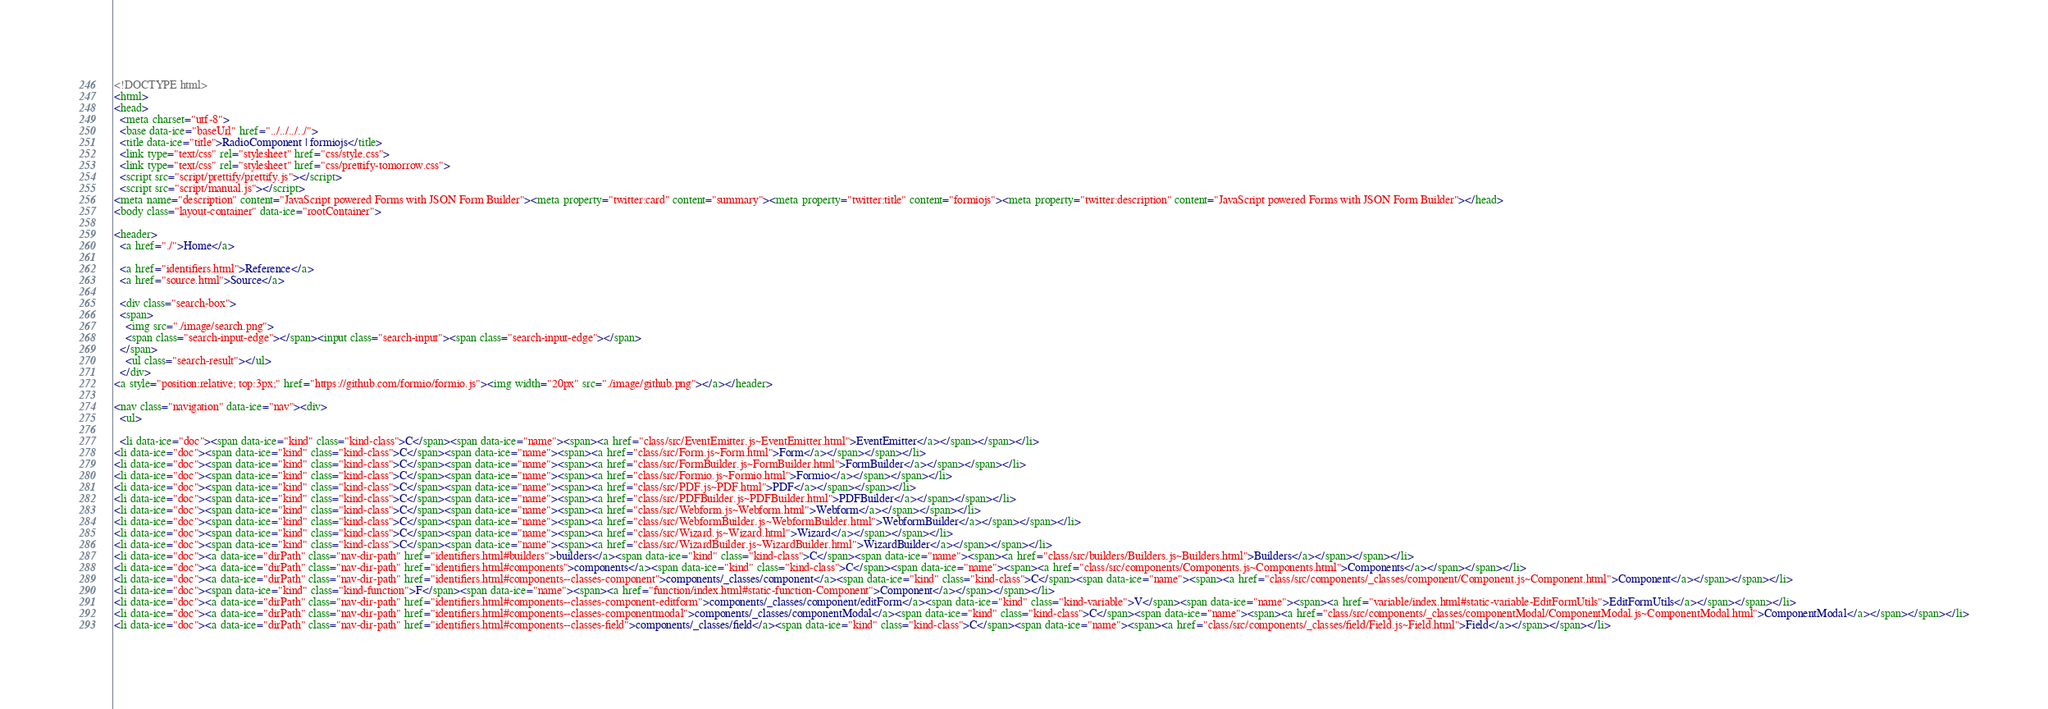<code> <loc_0><loc_0><loc_500><loc_500><_HTML_><!DOCTYPE html>
<html>
<head>
  <meta charset="utf-8">
  <base data-ice="baseUrl" href="../../../../">
  <title data-ice="title">RadioComponent | formiojs</title>
  <link type="text/css" rel="stylesheet" href="css/style.css">
  <link type="text/css" rel="stylesheet" href="css/prettify-tomorrow.css">
  <script src="script/prettify/prettify.js"></script>
  <script src="script/manual.js"></script>
<meta name="description" content="JavaScript powered Forms with JSON Form Builder"><meta property="twitter:card" content="summary"><meta property="twitter:title" content="formiojs"><meta property="twitter:description" content="JavaScript powered Forms with JSON Form Builder"></head>
<body class="layout-container" data-ice="rootContainer">

<header>
  <a href="./">Home</a>
  
  <a href="identifiers.html">Reference</a>
  <a href="source.html">Source</a>
  
  <div class="search-box">
  <span>
    <img src="./image/search.png">
    <span class="search-input-edge"></span><input class="search-input"><span class="search-input-edge"></span>
  </span>
    <ul class="search-result"></ul>
  </div>
<a style="position:relative; top:3px;" href="https://github.com/formio/formio.js"><img width="20px" src="./image/github.png"></a></header>

<nav class="navigation" data-ice="nav"><div>
  <ul>
    
  <li data-ice="doc"><span data-ice="kind" class="kind-class">C</span><span data-ice="name"><span><a href="class/src/EventEmitter.js~EventEmitter.html">EventEmitter</a></span></span></li>
<li data-ice="doc"><span data-ice="kind" class="kind-class">C</span><span data-ice="name"><span><a href="class/src/Form.js~Form.html">Form</a></span></span></li>
<li data-ice="doc"><span data-ice="kind" class="kind-class">C</span><span data-ice="name"><span><a href="class/src/FormBuilder.js~FormBuilder.html">FormBuilder</a></span></span></li>
<li data-ice="doc"><span data-ice="kind" class="kind-class">C</span><span data-ice="name"><span><a href="class/src/Formio.js~Formio.html">Formio</a></span></span></li>
<li data-ice="doc"><span data-ice="kind" class="kind-class">C</span><span data-ice="name"><span><a href="class/src/PDF.js~PDF.html">PDF</a></span></span></li>
<li data-ice="doc"><span data-ice="kind" class="kind-class">C</span><span data-ice="name"><span><a href="class/src/PDFBuilder.js~PDFBuilder.html">PDFBuilder</a></span></span></li>
<li data-ice="doc"><span data-ice="kind" class="kind-class">C</span><span data-ice="name"><span><a href="class/src/Webform.js~Webform.html">Webform</a></span></span></li>
<li data-ice="doc"><span data-ice="kind" class="kind-class">C</span><span data-ice="name"><span><a href="class/src/WebformBuilder.js~WebformBuilder.html">WebformBuilder</a></span></span></li>
<li data-ice="doc"><span data-ice="kind" class="kind-class">C</span><span data-ice="name"><span><a href="class/src/Wizard.js~Wizard.html">Wizard</a></span></span></li>
<li data-ice="doc"><span data-ice="kind" class="kind-class">C</span><span data-ice="name"><span><a href="class/src/WizardBuilder.js~WizardBuilder.html">WizardBuilder</a></span></span></li>
<li data-ice="doc"><a data-ice="dirPath" class="nav-dir-path" href="identifiers.html#builders">builders</a><span data-ice="kind" class="kind-class">C</span><span data-ice="name"><span><a href="class/src/builders/Builders.js~Builders.html">Builders</a></span></span></li>
<li data-ice="doc"><a data-ice="dirPath" class="nav-dir-path" href="identifiers.html#components">components</a><span data-ice="kind" class="kind-class">C</span><span data-ice="name"><span><a href="class/src/components/Components.js~Components.html">Components</a></span></span></li>
<li data-ice="doc"><a data-ice="dirPath" class="nav-dir-path" href="identifiers.html#components--classes-component">components/_classes/component</a><span data-ice="kind" class="kind-class">C</span><span data-ice="name"><span><a href="class/src/components/_classes/component/Component.js~Component.html">Component</a></span></span></li>
<li data-ice="doc"><span data-ice="kind" class="kind-function">F</span><span data-ice="name"><span><a href="function/index.html#static-function-Component">Component</a></span></span></li>
<li data-ice="doc"><a data-ice="dirPath" class="nav-dir-path" href="identifiers.html#components--classes-component-editform">components/_classes/component/editForm</a><span data-ice="kind" class="kind-variable">V</span><span data-ice="name"><span><a href="variable/index.html#static-variable-EditFormUtils">EditFormUtils</a></span></span></li>
<li data-ice="doc"><a data-ice="dirPath" class="nav-dir-path" href="identifiers.html#components--classes-componentmodal">components/_classes/componentModal</a><span data-ice="kind" class="kind-class">C</span><span data-ice="name"><span><a href="class/src/components/_classes/componentModal/ComponentModal.js~ComponentModal.html">ComponentModal</a></span></span></li>
<li data-ice="doc"><a data-ice="dirPath" class="nav-dir-path" href="identifiers.html#components--classes-field">components/_classes/field</a><span data-ice="kind" class="kind-class">C</span><span data-ice="name"><span><a href="class/src/components/_classes/field/Field.js~Field.html">Field</a></span></span></li></code> 